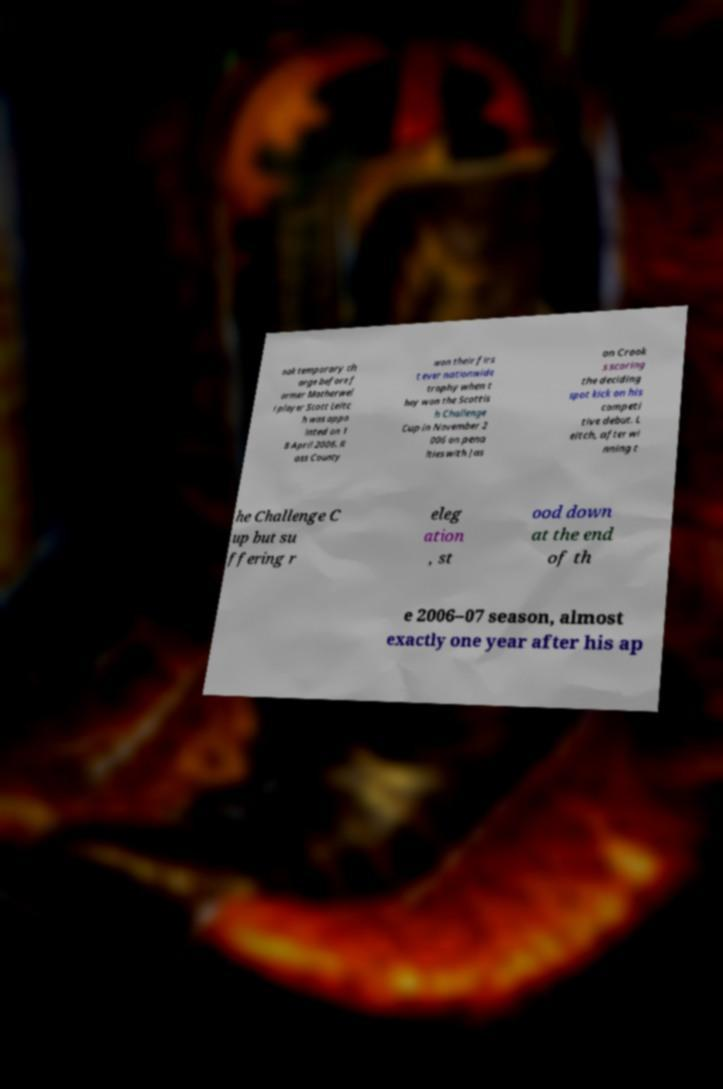I need the written content from this picture converted into text. Can you do that? ook temporary ch arge before f ormer Motherwel l player Scott Leitc h was appo inted on 1 8 April 2006. R oss County won their firs t ever nationwide trophy when t hey won the Scottis h Challenge Cup in November 2 006 on pena lties with Jas on Crook s scoring the deciding spot kick on his competi tive debut. L eitch, after wi nning t he Challenge C up but su ffering r eleg ation , st ood down at the end of th e 2006–07 season, almost exactly one year after his ap 